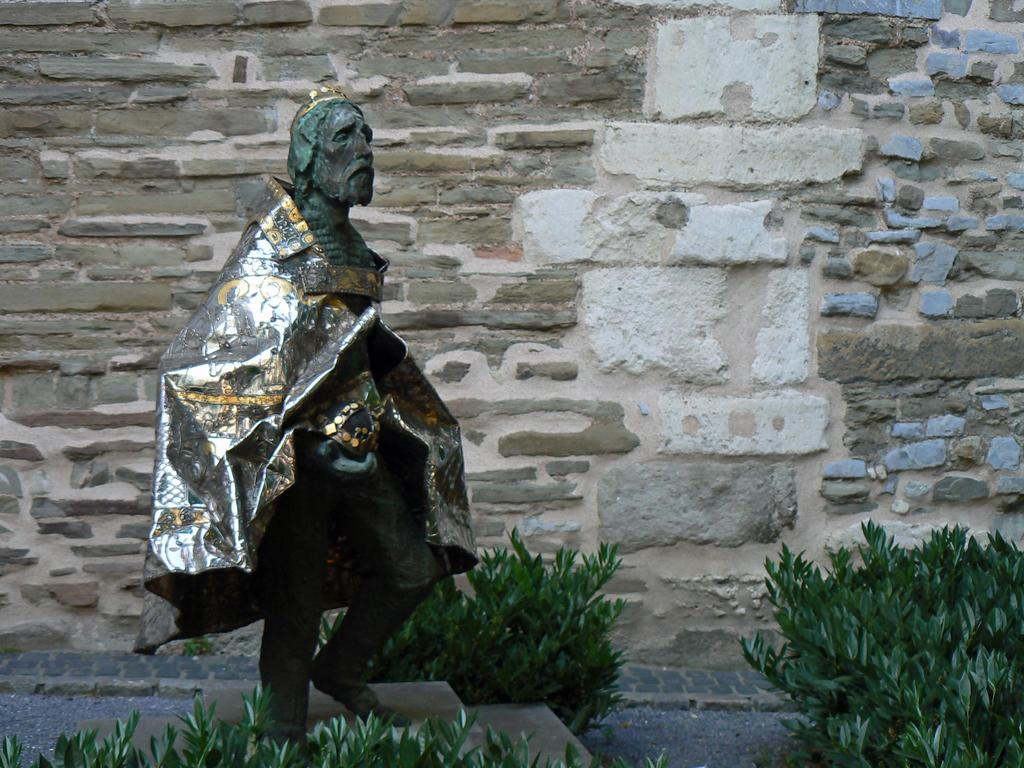What is located on the left side of the image? There is a statue on the left side of the image. What can be seen in the background of the image? There is a wall in the background of the image. What is visible at the bottom of the image? Plants and the ground are visible at the bottom of the image. How does the statue say good-bye to the bun in the image? There is no bun present in the image, and statues do not have the ability to say good-bye. 